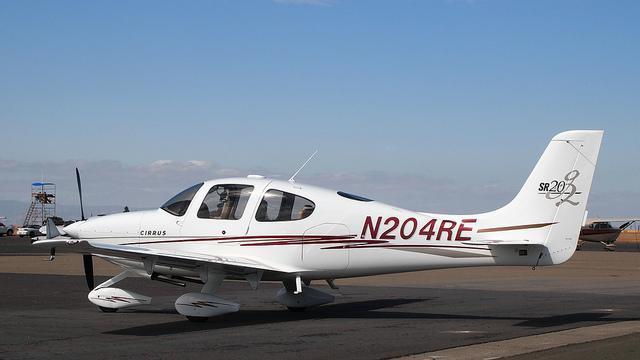How many planes are there?
Give a very brief answer. 2. 